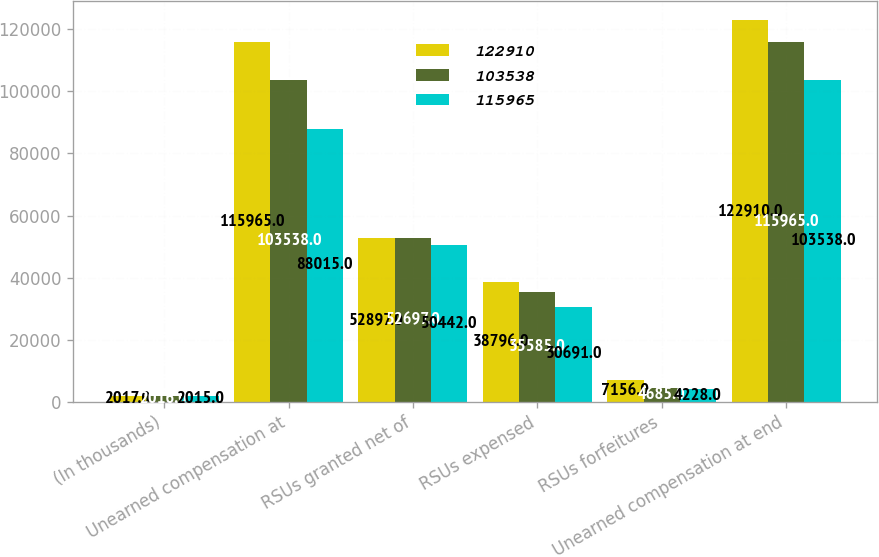Convert chart to OTSL. <chart><loc_0><loc_0><loc_500><loc_500><stacked_bar_chart><ecel><fcel>(In thousands)<fcel>Unearned compensation at<fcel>RSUs granted net of<fcel>RSUs expensed<fcel>RSUs forfeitures<fcel>Unearned compensation at end<nl><fcel>122910<fcel>2017<fcel>115965<fcel>52897<fcel>38796<fcel>7156<fcel>122910<nl><fcel>103538<fcel>2016<fcel>103538<fcel>52697<fcel>35585<fcel>4685<fcel>115965<nl><fcel>115965<fcel>2015<fcel>88015<fcel>50442<fcel>30691<fcel>4228<fcel>103538<nl></chart> 